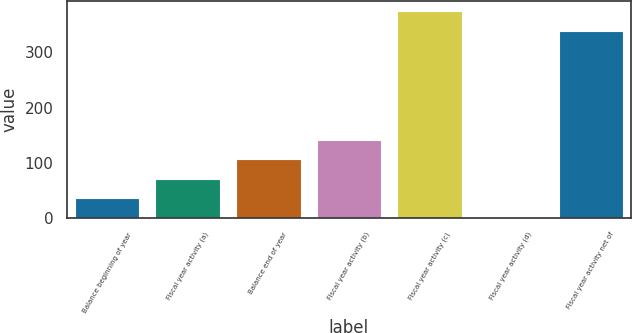<chart> <loc_0><loc_0><loc_500><loc_500><bar_chart><fcel>Balance beginning of year<fcel>Fiscal year activity (a)<fcel>Balance end of year<fcel>Fiscal year activity (b)<fcel>Fiscal year activity (c)<fcel>Fiscal year activity (d)<fcel>Fiscal year activity net of<nl><fcel>36.3<fcel>71.6<fcel>106.9<fcel>142.2<fcel>374.3<fcel>1<fcel>339<nl></chart> 